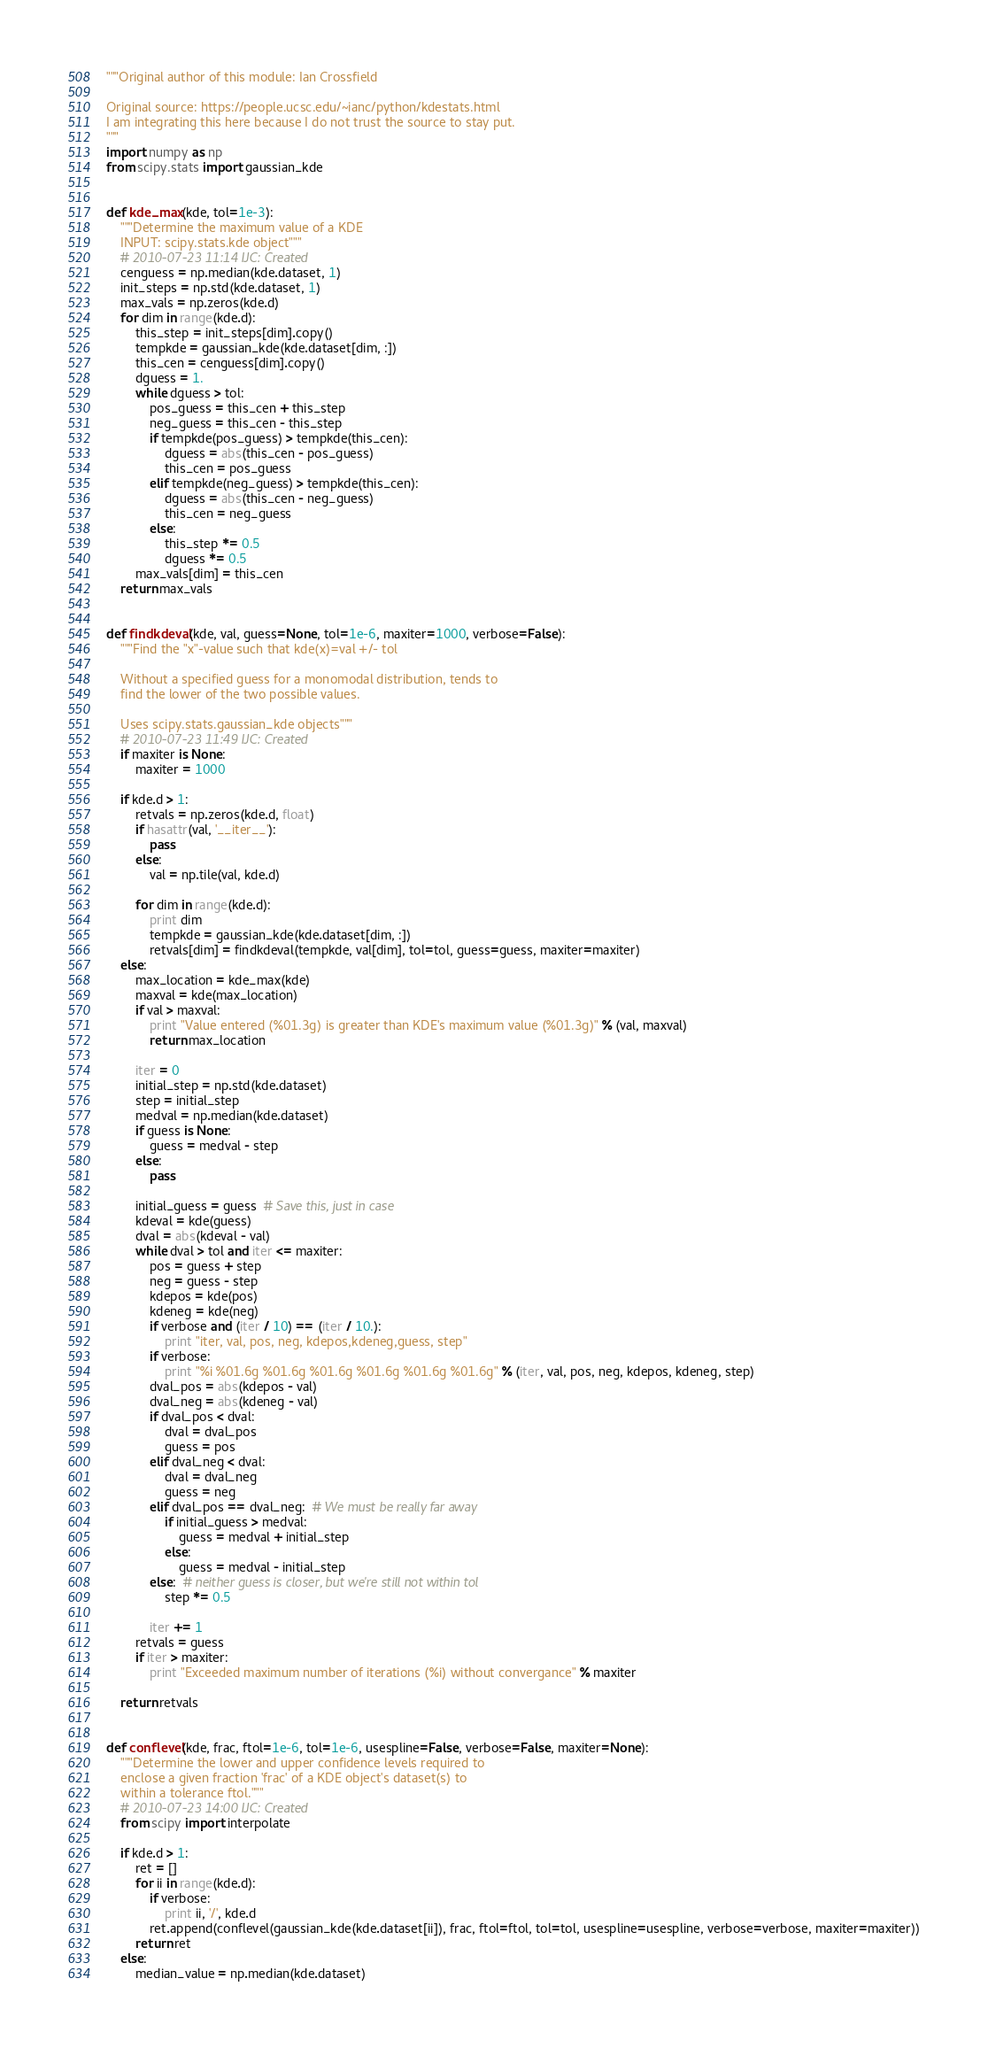Convert code to text. <code><loc_0><loc_0><loc_500><loc_500><_Python_>"""Original author of this module: Ian Crossfield

Original source: https://people.ucsc.edu/~ianc/python/kdestats.html
I am integrating this here because I do not trust the source to stay put.
"""
import numpy as np
from scipy.stats import gaussian_kde


def kde_max(kde, tol=1e-3):
    """Determine the maximum value of a KDE
    INPUT: scipy.stats.kde object"""
    # 2010-07-23 11:14 IJC: Created
    cenguess = np.median(kde.dataset, 1)
    init_steps = np.std(kde.dataset, 1)
    max_vals = np.zeros(kde.d)
    for dim in range(kde.d):
        this_step = init_steps[dim].copy()
        tempkde = gaussian_kde(kde.dataset[dim, :])
        this_cen = cenguess[dim].copy()
        dguess = 1.
        while dguess > tol:
            pos_guess = this_cen + this_step
            neg_guess = this_cen - this_step
            if tempkde(pos_guess) > tempkde(this_cen):
                dguess = abs(this_cen - pos_guess)
                this_cen = pos_guess
            elif tempkde(neg_guess) > tempkde(this_cen):
                dguess = abs(this_cen - neg_guess)
                this_cen = neg_guess
            else:
                this_step *= 0.5
                dguess *= 0.5
        max_vals[dim] = this_cen
    return max_vals


def findkdeval(kde, val, guess=None, tol=1e-6, maxiter=1000, verbose=False):
    """Find the "x"-value such that kde(x)=val +/- tol

    Without a specified guess for a monomodal distribution, tends to
    find the lower of the two possible values.

    Uses scipy.stats.gaussian_kde objects"""
    # 2010-07-23 11:49 IJC: Created
    if maxiter is None:
        maxiter = 1000

    if kde.d > 1:
        retvals = np.zeros(kde.d, float)
        if hasattr(val, '__iter__'):
            pass
        else:
            val = np.tile(val, kde.d)

        for dim in range(kde.d):
            print dim
            tempkde = gaussian_kde(kde.dataset[dim, :])
            retvals[dim] = findkdeval(tempkde, val[dim], tol=tol, guess=guess, maxiter=maxiter)
    else:
        max_location = kde_max(kde)
        maxval = kde(max_location)
        if val > maxval:
            print "Value entered (%01.3g) is greater than KDE's maximum value (%01.3g)" % (val, maxval)
            return max_location

        iter = 0
        initial_step = np.std(kde.dataset)
        step = initial_step
        medval = np.median(kde.dataset)
        if guess is None:
            guess = medval - step
        else:
            pass

        initial_guess = guess  # Save this, just in case
        kdeval = kde(guess)
        dval = abs(kdeval - val)
        while dval > tol and iter <= maxiter:
            pos = guess + step
            neg = guess - step
            kdepos = kde(pos)
            kdeneg = kde(neg)
            if verbose and (iter / 10) == (iter / 10.):
                print "iter, val, pos, neg, kdepos,kdeneg,guess, step"
            if verbose:
                print "%i %01.6g %01.6g %01.6g %01.6g %01.6g %01.6g" % (iter, val, pos, neg, kdepos, kdeneg, step)
            dval_pos = abs(kdepos - val)
            dval_neg = abs(kdeneg - val)
            if dval_pos < dval:
                dval = dval_pos
                guess = pos
            elif dval_neg < dval:
                dval = dval_neg
                guess = neg
            elif dval_pos == dval_neg:  # We must be really far away
                if initial_guess > medval:
                    guess = medval + initial_step
                else:
                    guess = medval - initial_step
            else:  # neither guess is closer, but we're still not within tol
                step *= 0.5

            iter += 1
        retvals = guess
        if iter > maxiter:
            print "Exceeded maximum number of iterations (%i) without convergance" % maxiter

    return retvals


def conflevel(kde, frac, ftol=1e-6, tol=1e-6, usespline=False, verbose=False, maxiter=None):
    """Determine the lower and upper confidence levels required to
    enclose a given fraction 'frac' of a KDE object's dataset(s) to
    within a tolerance ftol."""
    # 2010-07-23 14:00 IJC: Created
    from scipy import interpolate

    if kde.d > 1:
        ret = []
        for ii in range(kde.d):
            if verbose:
                print ii, '/', kde.d
            ret.append(conflevel(gaussian_kde(kde.dataset[ii]), frac, ftol=ftol, tol=tol, usespline=usespline, verbose=verbose, maxiter=maxiter))
        return ret
    else:
        median_value = np.median(kde.dataset)</code> 